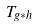Convert formula to latex. <formula><loc_0><loc_0><loc_500><loc_500>T _ { g * h }</formula> 